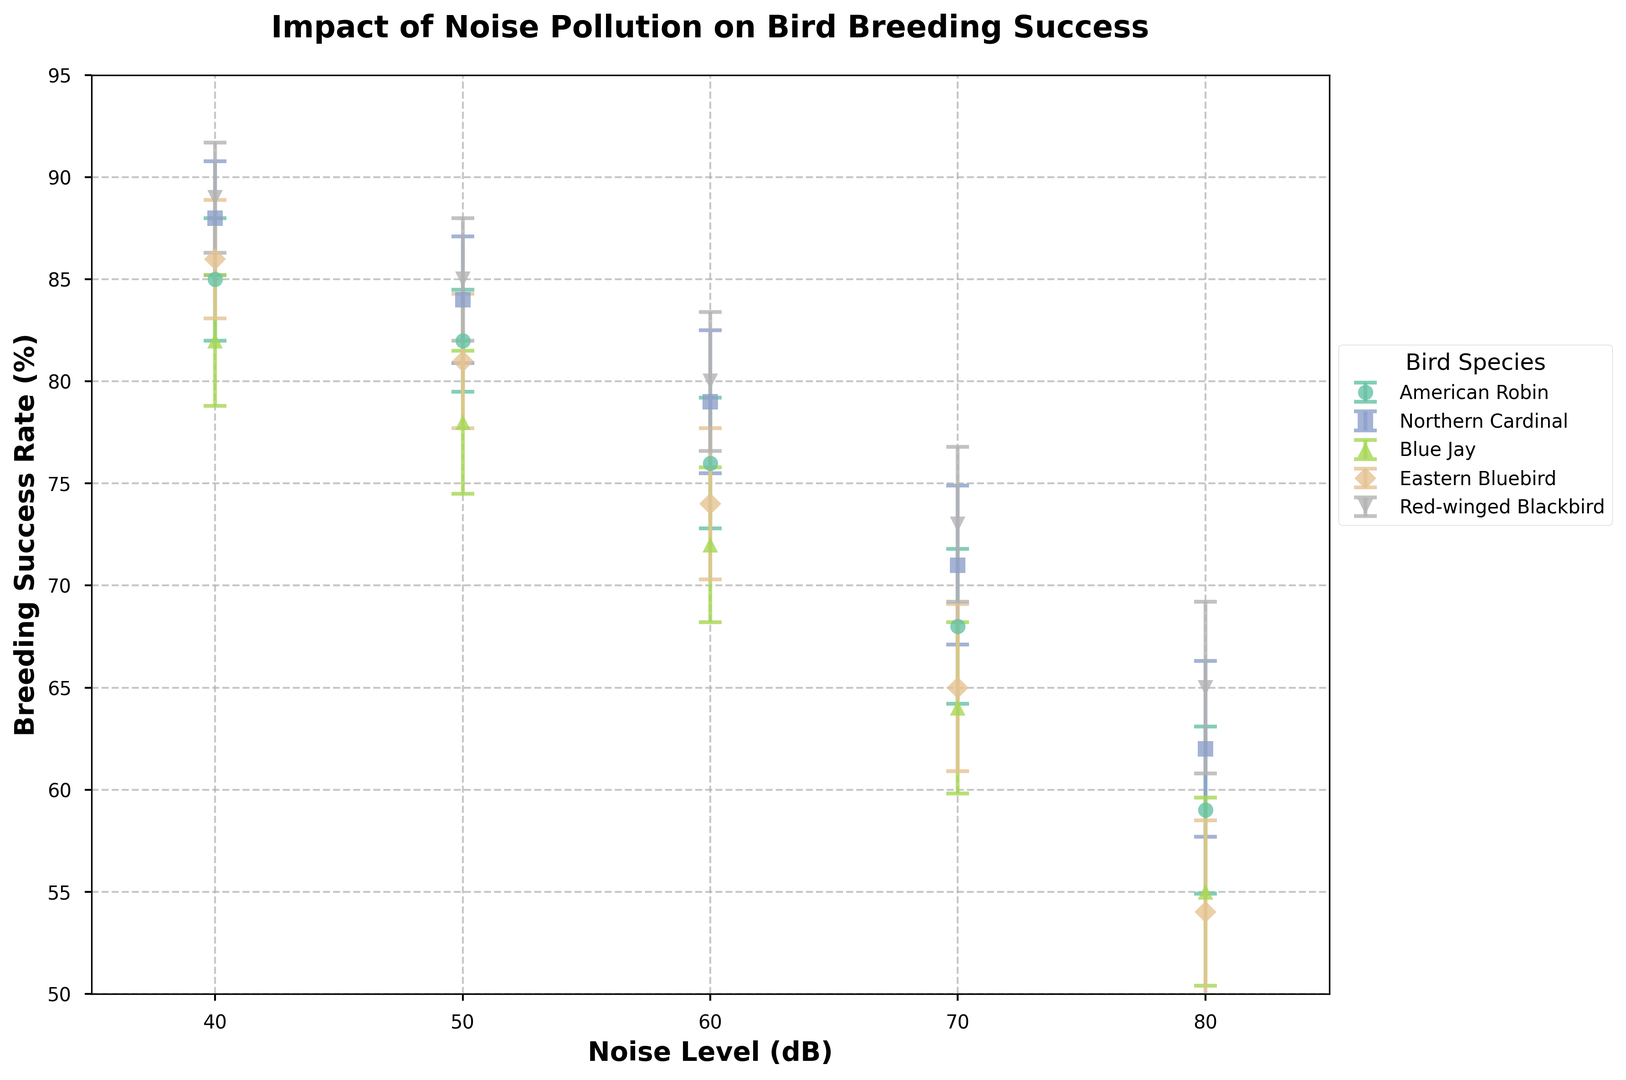Which bird species shows the highest breeding success rate at 40 dB noise level? Look for the highest value on the y-axis corresponding to the 40 dB mark for each bird species.
Answer: Red-winged Blackbird What is the difference in breeding success rates between Eastern Bluebird and Blue Jay at 60 dB noise level? Locate the breeding success rates for both species at 60 dB. Eastern Bluebird is at 74%, and Blue Jay is at 72%. Subtract the lower value from the higher value.
Answer: 2% Which species has the steepest decline in breeding success rates from 40 dB to 80 dB noise level? Calculate the difference in breeding success rates for each species between 40 dB and 80 dB noise levels. The species with the largest difference has the steepest decline.
Answer: Blue Jay At 70 dB noise level, does the Northern Cardinal or American Robin have a higher breeding success rate, and by how much? Locate the breeding success rates for both species at 70 dB. Northern Cardinal is at 71%, and American Robin is at 68%. Subtract the lower value from the higher value.
Answer: Northern Cardinal by 3% What is the average breeding success rate of American Robin across all noise levels? Add the breeding success rates of American Robin at all noise levels (85+82+76+68+59) and then divide by the number of data points (5).
Answer: 74% Which bird species has the highest error margin at 80 dB noise level? Check the error margins for each bird species at 80 dB and identify the highest value.
Answer: Blue Jay Compare the breeding success rates of all bird species at 50 dB noise level. Which species has the lowest rate? Compare the breeding success rates at 50 dB for all species: American Robin (82%), Northern Cardinal (84%), Blue Jay (78%), Eastern Bluebird (81%), and Red-winged Blackbird (85%). Identify the lowest value.
Answer: Blue Jay How does the breeding success rate change for Northern Cardinal from 40 dB to 60 dB noise levels? Look at the breeding success rates for Northern Cardinal at 40 dB (88%), 50 dB (84%), and 60 dB (79%). Calculate the differences between these levels.
Answer: Decreases by 4%, then by 5% Are the error margins consistently increasing for Eastern Bluebird as noise levels increase? Observe the error margins for Eastern Bluebird at each noise level: 40 dB (2.9%), 50 dB (3.3%), 60 dB (3.7%), 70 dB (4.1%), and 80 dB (4.5%). Check the trend.
Answer: Yes 